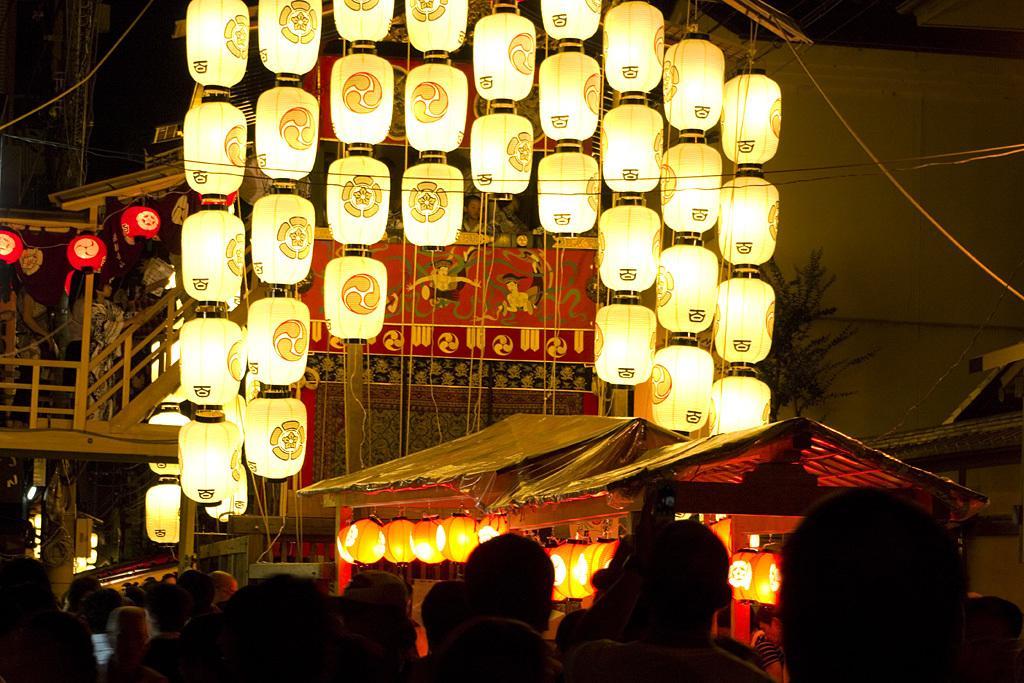Please provide a concise description of this image. In the image there are many lights hanging to the ceiling and the front there are many people walking, there are two stalls on the right side, this is clicked in the street at night time, in the back it seems to be building. 